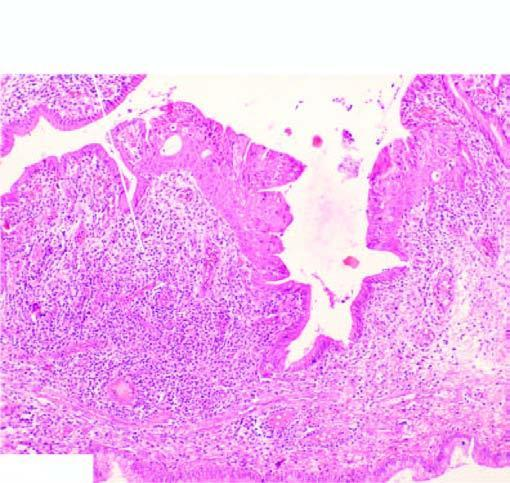re foci of metaplastic squamous epithelium seen at other places?
Answer the question using a single word or phrase. Yes 